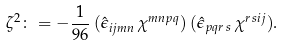Convert formula to latex. <formula><loc_0><loc_0><loc_500><loc_500>\zeta ^ { 2 } \colon = - \frac { 1 } { 9 6 } \, ( { \hat { \epsilon } } _ { i j m n } \, \chi ^ { m n p q } ) \, ( { \hat { \epsilon } } _ { p q r \, s } \, \chi ^ { r \, s i j } ) .</formula> 